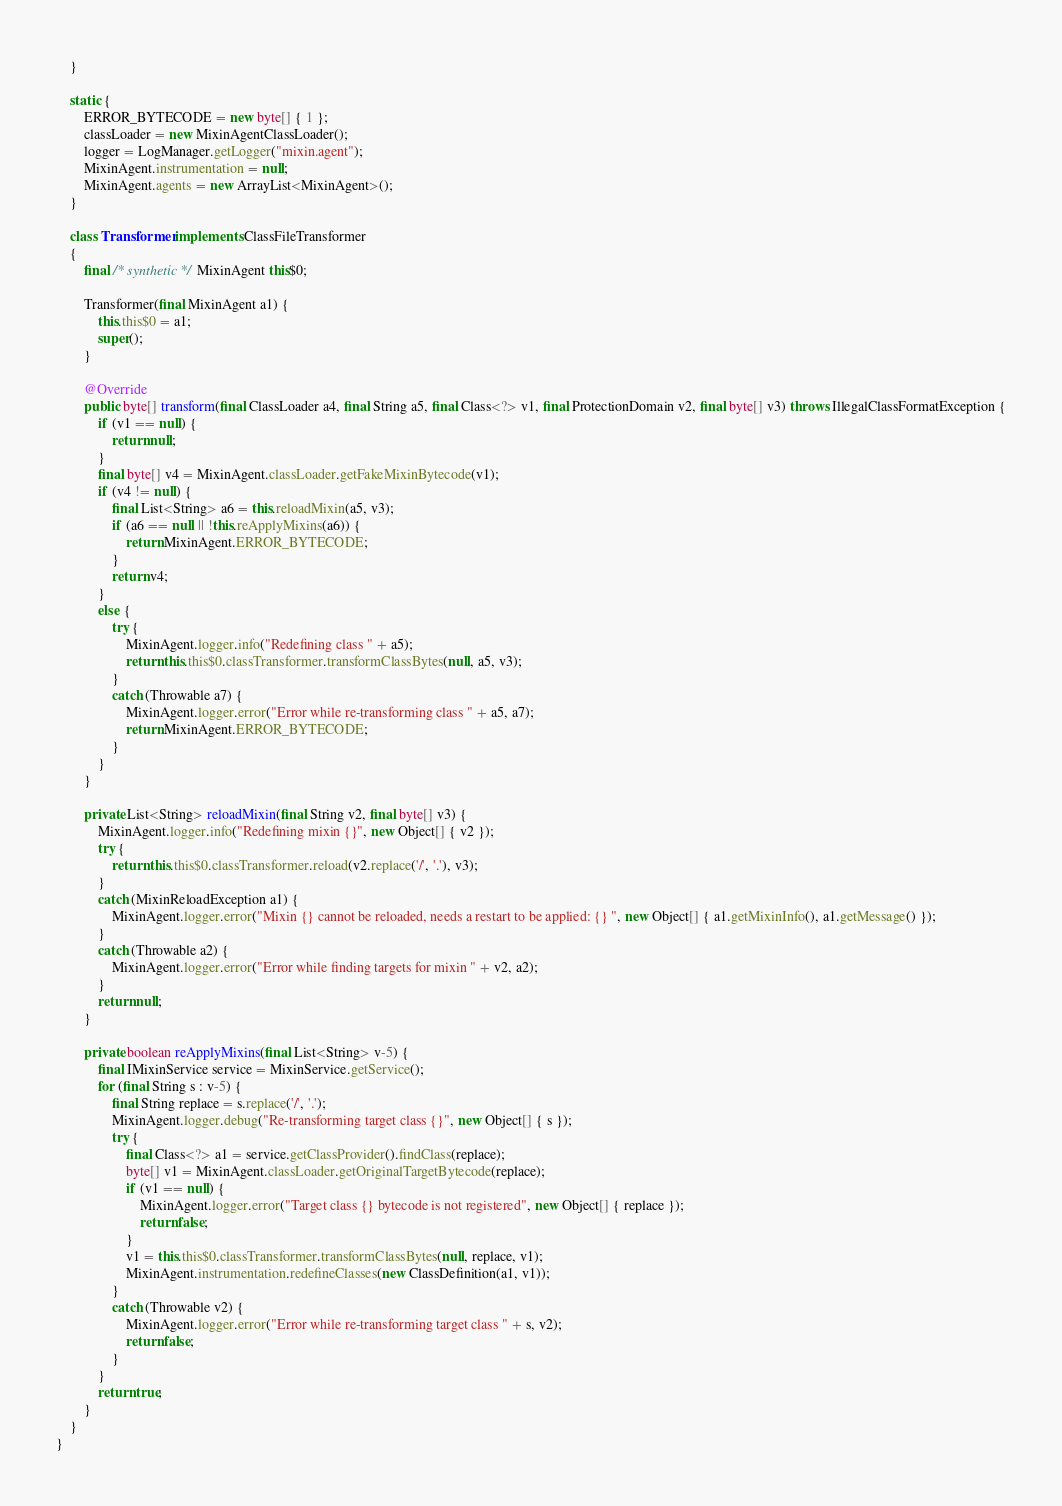<code> <loc_0><loc_0><loc_500><loc_500><_Java_>    }
    
    static {
        ERROR_BYTECODE = new byte[] { 1 };
        classLoader = new MixinAgentClassLoader();
        logger = LogManager.getLogger("mixin.agent");
        MixinAgent.instrumentation = null;
        MixinAgent.agents = new ArrayList<MixinAgent>();
    }
    
    class Transformer implements ClassFileTransformer
    {
        final /* synthetic */ MixinAgent this$0;
        
        Transformer(final MixinAgent a1) {
            this.this$0 = a1;
            super();
        }
        
        @Override
        public byte[] transform(final ClassLoader a4, final String a5, final Class<?> v1, final ProtectionDomain v2, final byte[] v3) throws IllegalClassFormatException {
            if (v1 == null) {
                return null;
            }
            final byte[] v4 = MixinAgent.classLoader.getFakeMixinBytecode(v1);
            if (v4 != null) {
                final List<String> a6 = this.reloadMixin(a5, v3);
                if (a6 == null || !this.reApplyMixins(a6)) {
                    return MixinAgent.ERROR_BYTECODE;
                }
                return v4;
            }
            else {
                try {
                    MixinAgent.logger.info("Redefining class " + a5);
                    return this.this$0.classTransformer.transformClassBytes(null, a5, v3);
                }
                catch (Throwable a7) {
                    MixinAgent.logger.error("Error while re-transforming class " + a5, a7);
                    return MixinAgent.ERROR_BYTECODE;
                }
            }
        }
        
        private List<String> reloadMixin(final String v2, final byte[] v3) {
            MixinAgent.logger.info("Redefining mixin {}", new Object[] { v2 });
            try {
                return this.this$0.classTransformer.reload(v2.replace('/', '.'), v3);
            }
            catch (MixinReloadException a1) {
                MixinAgent.logger.error("Mixin {} cannot be reloaded, needs a restart to be applied: {} ", new Object[] { a1.getMixinInfo(), a1.getMessage() });
            }
            catch (Throwable a2) {
                MixinAgent.logger.error("Error while finding targets for mixin " + v2, a2);
            }
            return null;
        }
        
        private boolean reApplyMixins(final List<String> v-5) {
            final IMixinService service = MixinService.getService();
            for (final String s : v-5) {
                final String replace = s.replace('/', '.');
                MixinAgent.logger.debug("Re-transforming target class {}", new Object[] { s });
                try {
                    final Class<?> a1 = service.getClassProvider().findClass(replace);
                    byte[] v1 = MixinAgent.classLoader.getOriginalTargetBytecode(replace);
                    if (v1 == null) {
                        MixinAgent.logger.error("Target class {} bytecode is not registered", new Object[] { replace });
                        return false;
                    }
                    v1 = this.this$0.classTransformer.transformClassBytes(null, replace, v1);
                    MixinAgent.instrumentation.redefineClasses(new ClassDefinition(a1, v1));
                }
                catch (Throwable v2) {
                    MixinAgent.logger.error("Error while re-transforming target class " + s, v2);
                    return false;
                }
            }
            return true;
        }
    }
}
</code> 